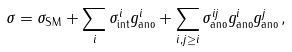Convert formula to latex. <formula><loc_0><loc_0><loc_500><loc_500>\sigma = \sigma _ { \text {SM} } + \sum _ { i } \sigma _ { \text {int} } ^ { i } g ^ { i } _ { \text {ano} } + \sum _ { i , j \geq i } \sigma _ { \text {ano} } ^ { i j } g _ { \text {ano} } ^ { i } g _ { \text {ano} } ^ { j } \, ,</formula> 